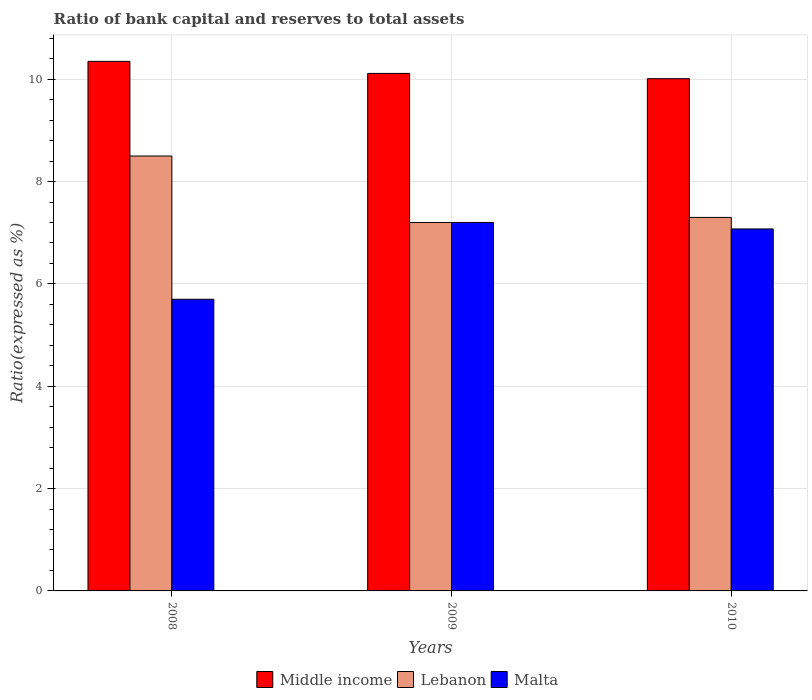What is the label of the 3rd group of bars from the left?
Offer a very short reply. 2010. What is the ratio of bank capital and reserves to total assets in Malta in 2010?
Offer a very short reply. 7.07. Across all years, what is the maximum ratio of bank capital and reserves to total assets in Middle income?
Offer a terse response. 10.35. Across all years, what is the minimum ratio of bank capital and reserves to total assets in Lebanon?
Make the answer very short. 7.2. In which year was the ratio of bank capital and reserves to total assets in Malta maximum?
Make the answer very short. 2009. What is the total ratio of bank capital and reserves to total assets in Lebanon in the graph?
Keep it short and to the point. 23. What is the difference between the ratio of bank capital and reserves to total assets in Middle income in 2009 and that in 2010?
Give a very brief answer. 0.1. What is the difference between the ratio of bank capital and reserves to total assets in Middle income in 2008 and the ratio of bank capital and reserves to total assets in Lebanon in 2009?
Your response must be concise. 3.15. What is the average ratio of bank capital and reserves to total assets in Malta per year?
Give a very brief answer. 6.66. In the year 2009, what is the difference between the ratio of bank capital and reserves to total assets in Middle income and ratio of bank capital and reserves to total assets in Malta?
Ensure brevity in your answer.  2.91. What is the ratio of the ratio of bank capital and reserves to total assets in Lebanon in 2008 to that in 2009?
Provide a short and direct response. 1.18. Is the difference between the ratio of bank capital and reserves to total assets in Middle income in 2008 and 2010 greater than the difference between the ratio of bank capital and reserves to total assets in Malta in 2008 and 2010?
Your answer should be very brief. Yes. What is the difference between the highest and the second highest ratio of bank capital and reserves to total assets in Middle income?
Your answer should be very brief. 0.24. What is the difference between the highest and the lowest ratio of bank capital and reserves to total assets in Lebanon?
Give a very brief answer. 1.3. In how many years, is the ratio of bank capital and reserves to total assets in Middle income greater than the average ratio of bank capital and reserves to total assets in Middle income taken over all years?
Ensure brevity in your answer.  1. Is the sum of the ratio of bank capital and reserves to total assets in Malta in 2008 and 2010 greater than the maximum ratio of bank capital and reserves to total assets in Middle income across all years?
Offer a very short reply. Yes. What does the 1st bar from the left in 2008 represents?
Make the answer very short. Middle income. What does the 2nd bar from the right in 2010 represents?
Offer a very short reply. Lebanon. How many bars are there?
Offer a very short reply. 9. Are the values on the major ticks of Y-axis written in scientific E-notation?
Ensure brevity in your answer.  No. Does the graph contain grids?
Offer a terse response. Yes. Where does the legend appear in the graph?
Give a very brief answer. Bottom center. How many legend labels are there?
Offer a terse response. 3. What is the title of the graph?
Offer a terse response. Ratio of bank capital and reserves to total assets. Does "Germany" appear as one of the legend labels in the graph?
Make the answer very short. No. What is the label or title of the X-axis?
Make the answer very short. Years. What is the label or title of the Y-axis?
Make the answer very short. Ratio(expressed as %). What is the Ratio(expressed as %) in Middle income in 2008?
Give a very brief answer. 10.35. What is the Ratio(expressed as %) of Malta in 2008?
Offer a very short reply. 5.7. What is the Ratio(expressed as %) in Middle income in 2009?
Provide a succinct answer. 10.11. What is the Ratio(expressed as %) in Malta in 2009?
Give a very brief answer. 7.2. What is the Ratio(expressed as %) in Middle income in 2010?
Give a very brief answer. 10.01. What is the Ratio(expressed as %) of Malta in 2010?
Keep it short and to the point. 7.07. Across all years, what is the maximum Ratio(expressed as %) of Middle income?
Make the answer very short. 10.35. Across all years, what is the maximum Ratio(expressed as %) of Malta?
Your answer should be very brief. 7.2. Across all years, what is the minimum Ratio(expressed as %) of Middle income?
Keep it short and to the point. 10.01. Across all years, what is the minimum Ratio(expressed as %) in Lebanon?
Offer a terse response. 7.2. Across all years, what is the minimum Ratio(expressed as %) in Malta?
Make the answer very short. 5.7. What is the total Ratio(expressed as %) of Middle income in the graph?
Your answer should be compact. 30.48. What is the total Ratio(expressed as %) in Lebanon in the graph?
Ensure brevity in your answer.  23. What is the total Ratio(expressed as %) in Malta in the graph?
Keep it short and to the point. 19.98. What is the difference between the Ratio(expressed as %) of Middle income in 2008 and that in 2009?
Your answer should be compact. 0.24. What is the difference between the Ratio(expressed as %) of Malta in 2008 and that in 2009?
Your response must be concise. -1.5. What is the difference between the Ratio(expressed as %) of Middle income in 2008 and that in 2010?
Provide a short and direct response. 0.34. What is the difference between the Ratio(expressed as %) of Lebanon in 2008 and that in 2010?
Offer a terse response. 1.2. What is the difference between the Ratio(expressed as %) in Malta in 2008 and that in 2010?
Provide a succinct answer. -1.37. What is the difference between the Ratio(expressed as %) in Middle income in 2009 and that in 2010?
Make the answer very short. 0.1. What is the difference between the Ratio(expressed as %) of Malta in 2009 and that in 2010?
Provide a succinct answer. 0.13. What is the difference between the Ratio(expressed as %) in Middle income in 2008 and the Ratio(expressed as %) in Lebanon in 2009?
Provide a short and direct response. 3.15. What is the difference between the Ratio(expressed as %) in Middle income in 2008 and the Ratio(expressed as %) in Malta in 2009?
Offer a very short reply. 3.15. What is the difference between the Ratio(expressed as %) of Lebanon in 2008 and the Ratio(expressed as %) of Malta in 2009?
Provide a succinct answer. 1.3. What is the difference between the Ratio(expressed as %) of Middle income in 2008 and the Ratio(expressed as %) of Lebanon in 2010?
Ensure brevity in your answer.  3.05. What is the difference between the Ratio(expressed as %) in Middle income in 2008 and the Ratio(expressed as %) in Malta in 2010?
Provide a short and direct response. 3.28. What is the difference between the Ratio(expressed as %) in Lebanon in 2008 and the Ratio(expressed as %) in Malta in 2010?
Your answer should be compact. 1.43. What is the difference between the Ratio(expressed as %) of Middle income in 2009 and the Ratio(expressed as %) of Lebanon in 2010?
Your answer should be compact. 2.81. What is the difference between the Ratio(expressed as %) of Middle income in 2009 and the Ratio(expressed as %) of Malta in 2010?
Provide a short and direct response. 3.04. What is the difference between the Ratio(expressed as %) in Lebanon in 2009 and the Ratio(expressed as %) in Malta in 2010?
Offer a very short reply. 0.13. What is the average Ratio(expressed as %) in Middle income per year?
Give a very brief answer. 10.16. What is the average Ratio(expressed as %) in Lebanon per year?
Make the answer very short. 7.67. What is the average Ratio(expressed as %) in Malta per year?
Make the answer very short. 6.66. In the year 2008, what is the difference between the Ratio(expressed as %) of Middle income and Ratio(expressed as %) of Lebanon?
Ensure brevity in your answer.  1.85. In the year 2008, what is the difference between the Ratio(expressed as %) of Middle income and Ratio(expressed as %) of Malta?
Offer a very short reply. 4.65. In the year 2009, what is the difference between the Ratio(expressed as %) of Middle income and Ratio(expressed as %) of Lebanon?
Offer a terse response. 2.91. In the year 2009, what is the difference between the Ratio(expressed as %) of Middle income and Ratio(expressed as %) of Malta?
Your response must be concise. 2.91. In the year 2009, what is the difference between the Ratio(expressed as %) in Lebanon and Ratio(expressed as %) in Malta?
Make the answer very short. -0. In the year 2010, what is the difference between the Ratio(expressed as %) of Middle income and Ratio(expressed as %) of Lebanon?
Your answer should be very brief. 2.71. In the year 2010, what is the difference between the Ratio(expressed as %) in Middle income and Ratio(expressed as %) in Malta?
Keep it short and to the point. 2.94. In the year 2010, what is the difference between the Ratio(expressed as %) of Lebanon and Ratio(expressed as %) of Malta?
Your response must be concise. 0.23. What is the ratio of the Ratio(expressed as %) in Middle income in 2008 to that in 2009?
Make the answer very short. 1.02. What is the ratio of the Ratio(expressed as %) of Lebanon in 2008 to that in 2009?
Keep it short and to the point. 1.18. What is the ratio of the Ratio(expressed as %) of Malta in 2008 to that in 2009?
Make the answer very short. 0.79. What is the ratio of the Ratio(expressed as %) of Middle income in 2008 to that in 2010?
Make the answer very short. 1.03. What is the ratio of the Ratio(expressed as %) of Lebanon in 2008 to that in 2010?
Your answer should be very brief. 1.16. What is the ratio of the Ratio(expressed as %) in Malta in 2008 to that in 2010?
Your response must be concise. 0.81. What is the ratio of the Ratio(expressed as %) in Middle income in 2009 to that in 2010?
Offer a terse response. 1.01. What is the ratio of the Ratio(expressed as %) of Lebanon in 2009 to that in 2010?
Offer a terse response. 0.99. What is the ratio of the Ratio(expressed as %) in Malta in 2009 to that in 2010?
Offer a very short reply. 1.02. What is the difference between the highest and the second highest Ratio(expressed as %) of Middle income?
Ensure brevity in your answer.  0.24. What is the difference between the highest and the second highest Ratio(expressed as %) of Lebanon?
Your answer should be very brief. 1.2. What is the difference between the highest and the second highest Ratio(expressed as %) of Malta?
Offer a very short reply. 0.13. What is the difference between the highest and the lowest Ratio(expressed as %) of Middle income?
Provide a short and direct response. 0.34. What is the difference between the highest and the lowest Ratio(expressed as %) in Malta?
Your answer should be compact. 1.5. 